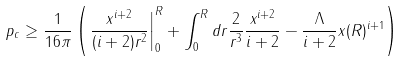<formula> <loc_0><loc_0><loc_500><loc_500>p _ { c } \geq \frac { 1 } { 1 6 \pi } \left ( \left . \frac { x ^ { i + 2 } } { ( i + 2 ) r ^ { 2 } } \right | _ { 0 } ^ { R } + \int _ { 0 } ^ { R } d r \frac { 2 } { r ^ { 3 } } \frac { x ^ { i + 2 } } { i + 2 } - \frac { \Lambda } { i + 2 } x ( R ) ^ { i + 1 } \right )</formula> 